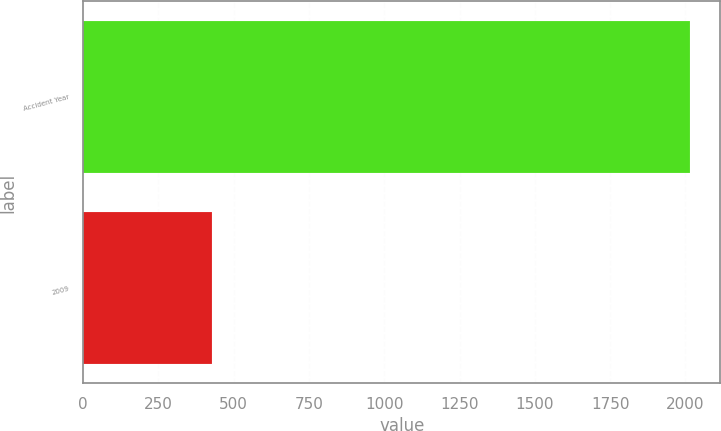Convert chart to OTSL. <chart><loc_0><loc_0><loc_500><loc_500><bar_chart><fcel>Accident Year<fcel>2009<nl><fcel>2015<fcel>429<nl></chart> 